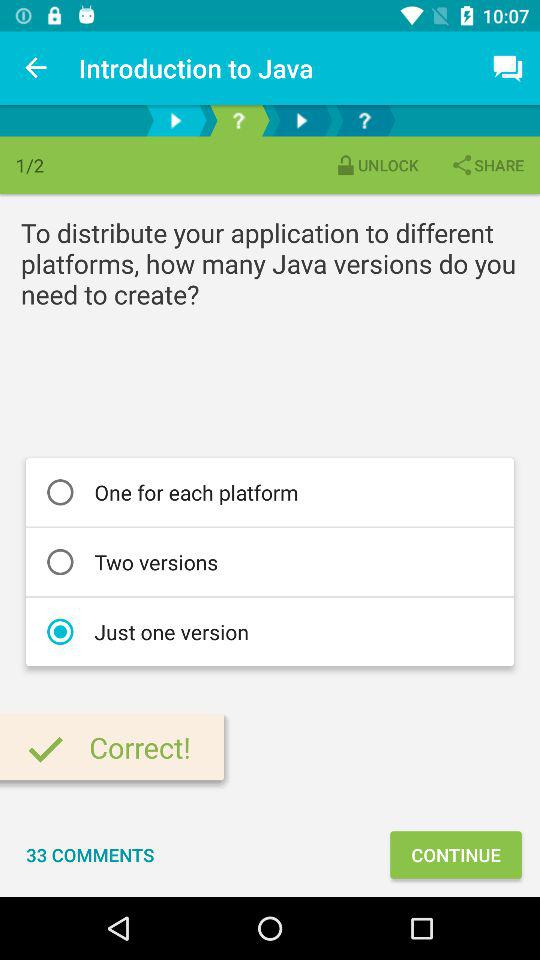How many pages are there in total? There are 2 pages in total. 